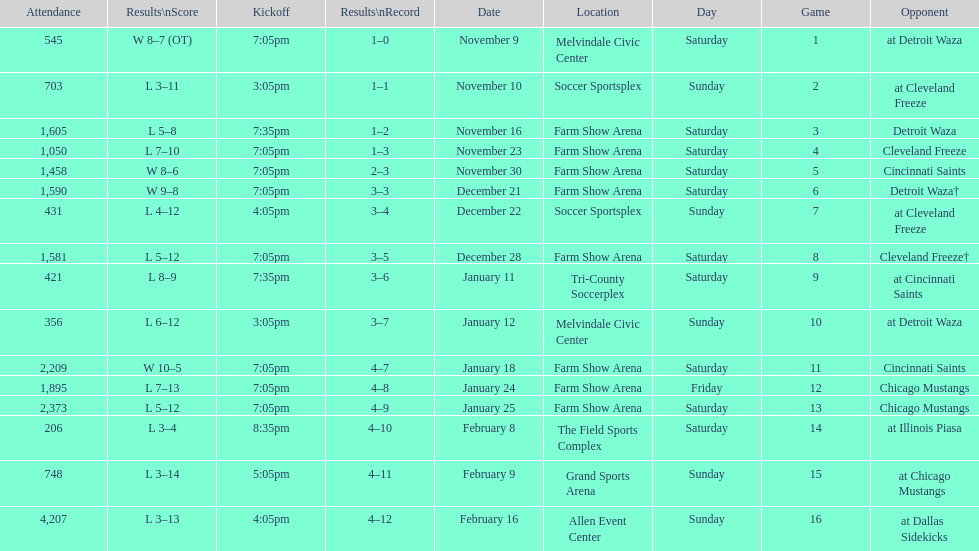Which opponent is listed after cleveland freeze in the table? Detroit Waza. 